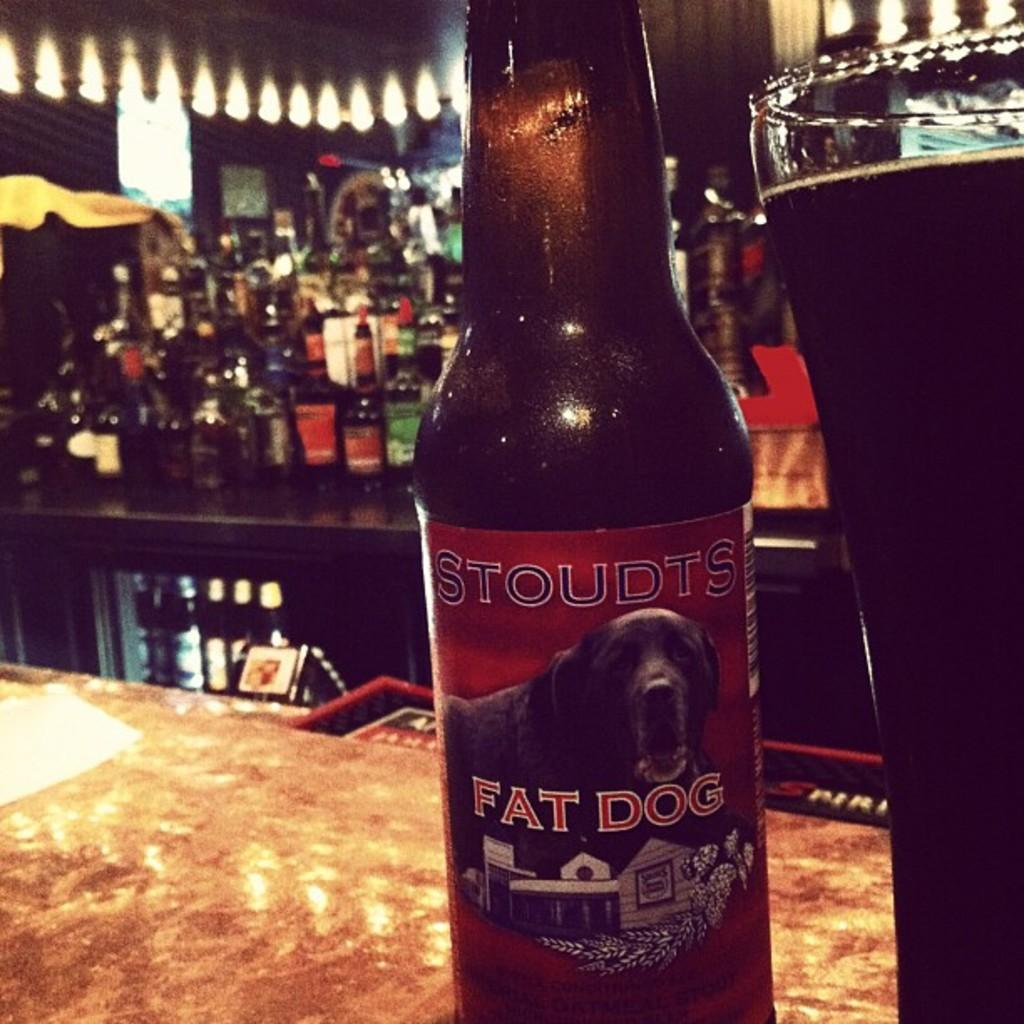<image>
Describe the image concisely. A bottle of Stoudts Fat Dog beer is on a bar counter. 